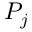Convert formula to latex. <formula><loc_0><loc_0><loc_500><loc_500>P _ { j }</formula> 